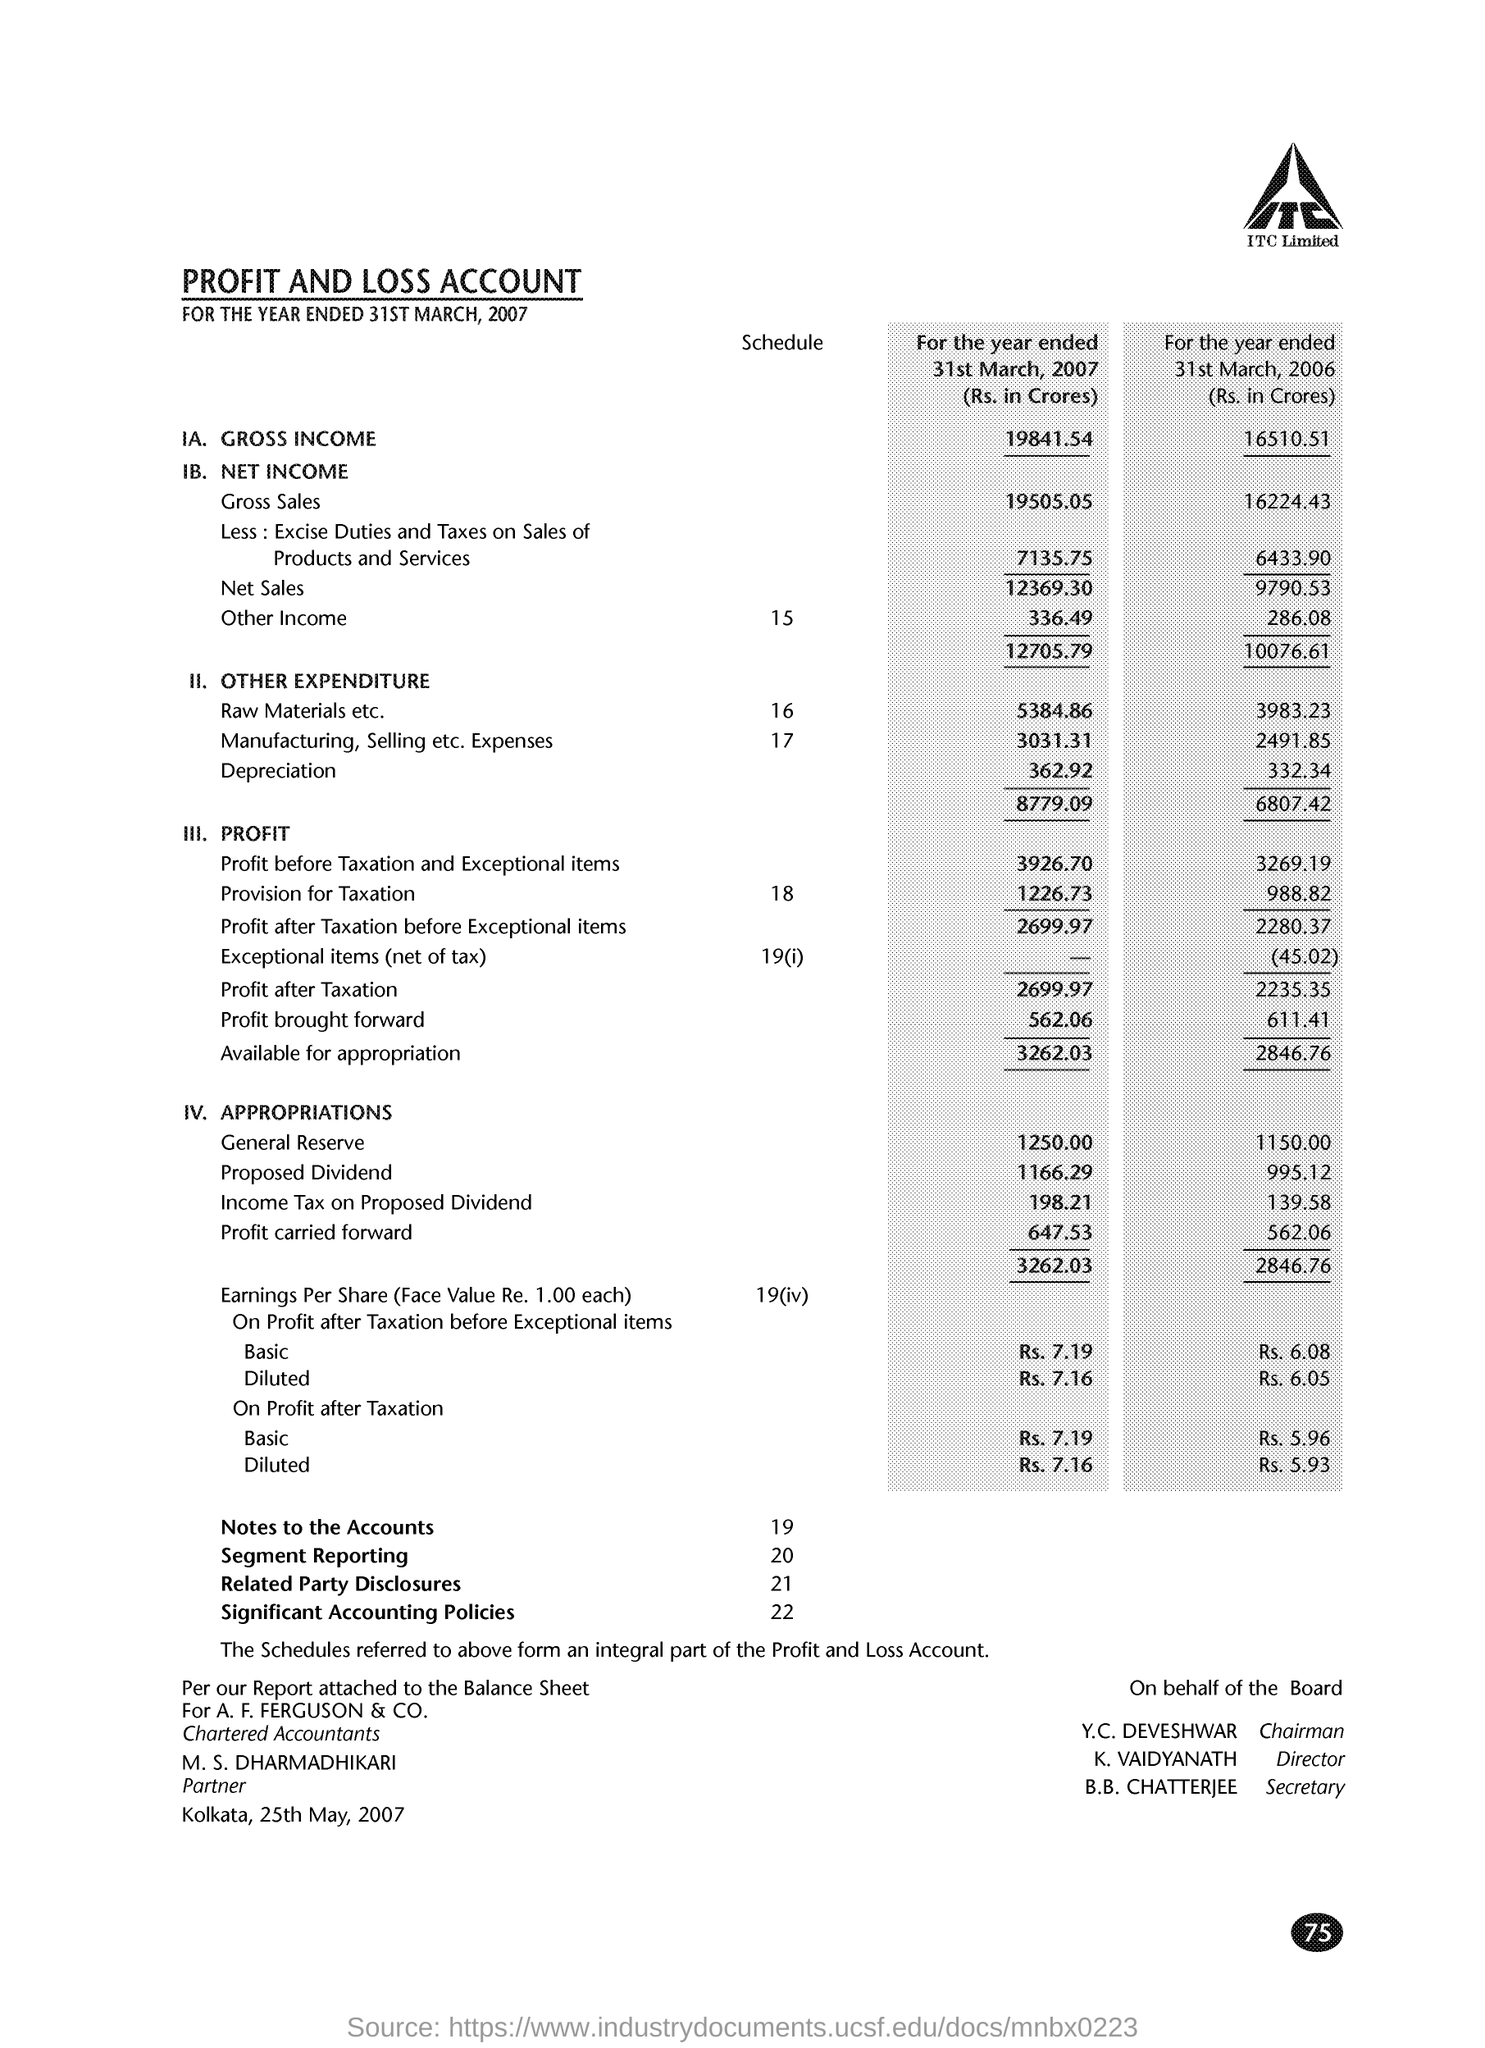Indicate a few pertinent items in this graphic. The profit for the year ended March 31, 2007, in crore rupees, was 2699.97. The profit and loss account for the period ending on March 31, 2007, has been given. 